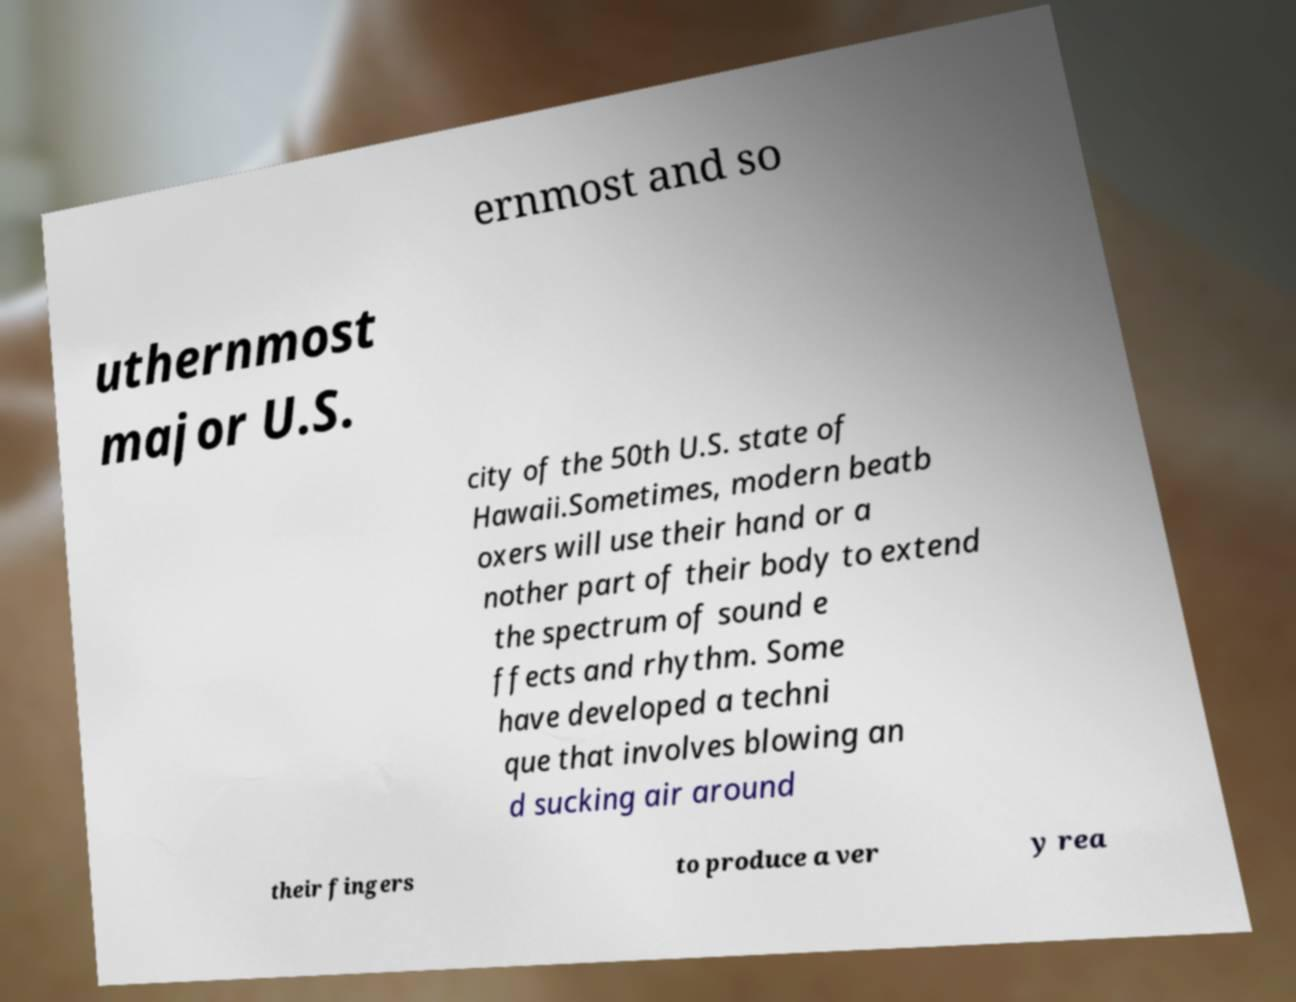For documentation purposes, I need the text within this image transcribed. Could you provide that? ernmost and so uthernmost major U.S. city of the 50th U.S. state of Hawaii.Sometimes, modern beatb oxers will use their hand or a nother part of their body to extend the spectrum of sound e ffects and rhythm. Some have developed a techni que that involves blowing an d sucking air around their fingers to produce a ver y rea 